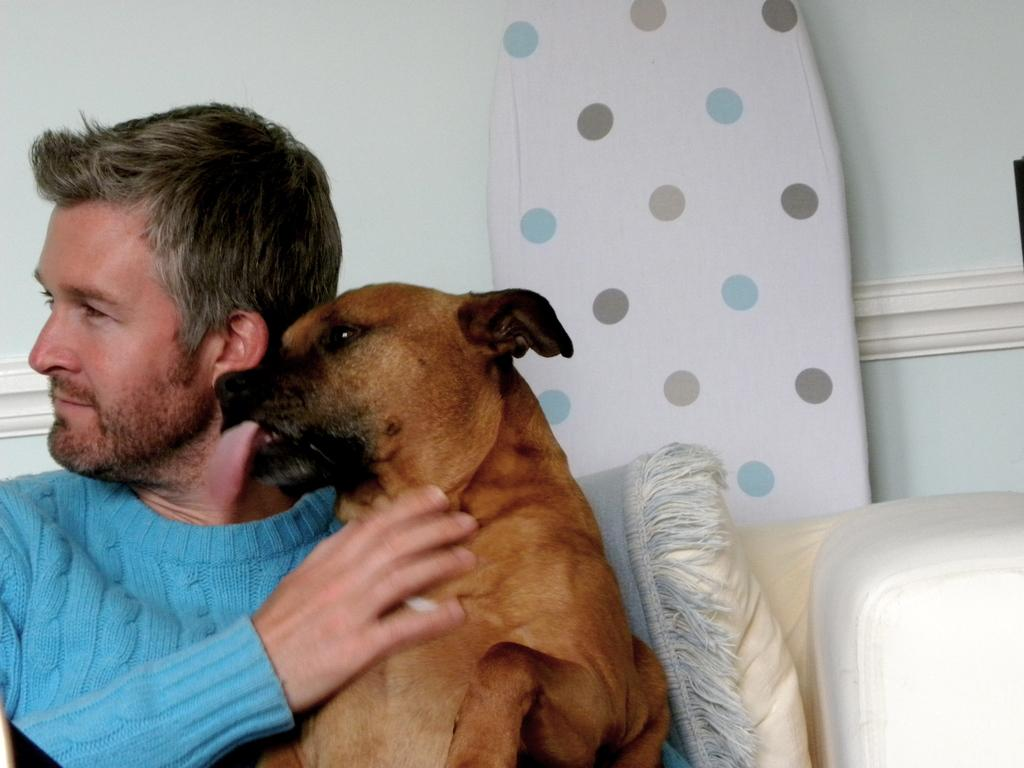What is the person in the image doing? The person is sitting on a chair and holding a dog with their hands. What can be seen in the background of the image? There is a wall in the background of the image. What type of education is the person receiving in the image? There is no indication of education in the image; it shows a person holding a dog. What kind of ink is being used for writing in the image? There is no writing or ink present in the image. 